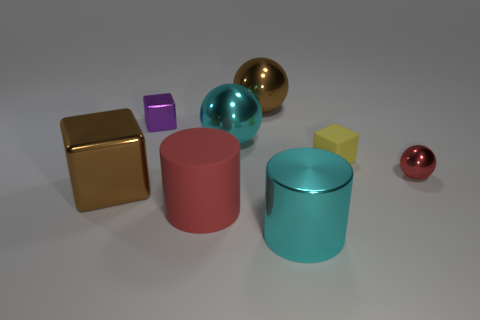Is the number of big brown metallic cubes behind the small red thing the same as the number of tiny cyan matte cylinders?
Provide a short and direct response. Yes. There is a metallic cylinder; is it the same color as the block that is right of the rubber cylinder?
Ensure brevity in your answer.  No. There is a cyan object that is behind the big red rubber cylinder in front of the tiny yellow matte object; is there a cube that is to the right of it?
Your response must be concise. Yes. Are there fewer yellow matte objects in front of the small red metallic object than brown blocks?
Provide a succinct answer. Yes. What number of other things are there of the same shape as the red matte thing?
Offer a very short reply. 1. How many things are either brown objects that are behind the small yellow rubber object or large brown objects behind the large cube?
Ensure brevity in your answer.  1. There is a object that is both in front of the big brown cube and right of the large rubber cylinder; what is its size?
Keep it short and to the point. Large. There is a large brown metallic object that is behind the large brown metallic block; is its shape the same as the purple metal thing?
Your answer should be very brief. No. There is a brown metal block that is to the left of the yellow object that is on the right side of the big cyan object that is in front of the tiny red thing; what is its size?
Keep it short and to the point. Large. The other thing that is the same color as the big rubber object is what size?
Make the answer very short. Small. 